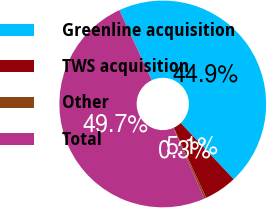<chart> <loc_0><loc_0><loc_500><loc_500><pie_chart><fcel>Greenline acquisition<fcel>TWS acquisition<fcel>Other<fcel>Total<nl><fcel>44.87%<fcel>5.13%<fcel>0.31%<fcel>49.69%<nl></chart> 